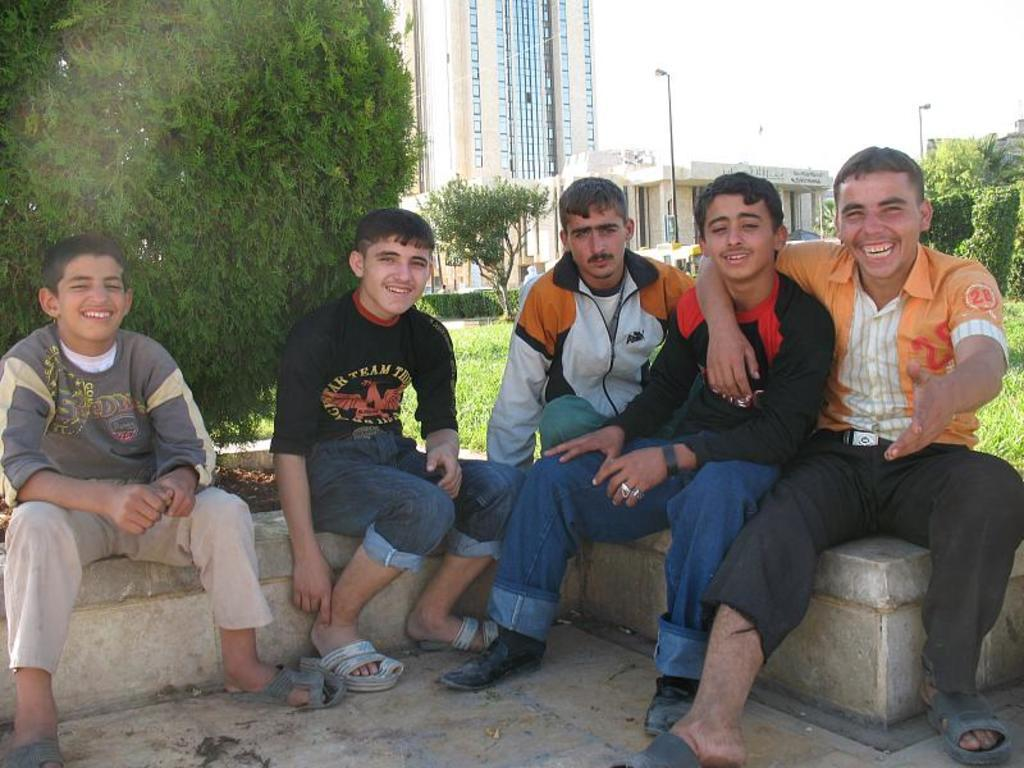How many people are in the image? There is a group of people in the image, but the exact number cannot be determined from the provided facts. What are the people doing in the image? The people are sitting on a surface and smiling. What can be seen in the background of the image? There are trees, buildings, poles, grass, and the sky visible in the background of the image. What type of oatmeal is being served to the people in the image? There is no oatmeal present in the image; the people are sitting and smiling. What kind of destruction can be seen in the image? There is no destruction present in the image; it features a group of people sitting and smiling, along with various background elements. 